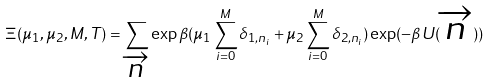<formula> <loc_0><loc_0><loc_500><loc_500>\Xi ( \mu _ { 1 } , \mu _ { 2 } , M , T ) = \sum _ { \overrightarrow { n } } \exp \beta ( \mu _ { 1 } \sum _ { i = 0 } ^ { M } \delta _ { 1 , n _ { i } } + \mu _ { 2 } \sum _ { i = 0 } ^ { M } \delta _ { 2 , n _ { i } } ) \exp ( - \beta U ( \overrightarrow { n } ) )</formula> 